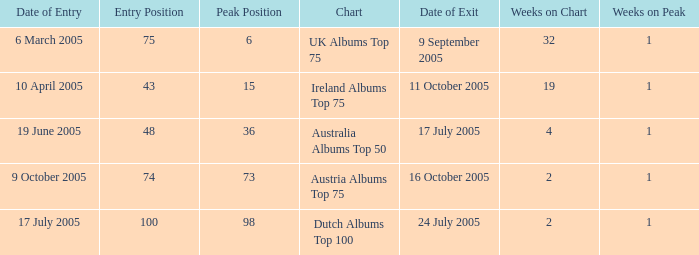What is the date of entry for the UK Albums Top 75 chart? 6 March 2005. 